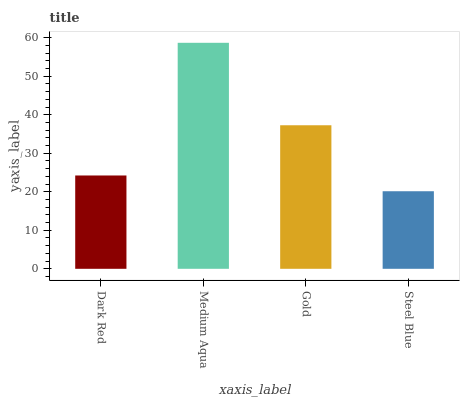Is Steel Blue the minimum?
Answer yes or no. Yes. Is Medium Aqua the maximum?
Answer yes or no. Yes. Is Gold the minimum?
Answer yes or no. No. Is Gold the maximum?
Answer yes or no. No. Is Medium Aqua greater than Gold?
Answer yes or no. Yes. Is Gold less than Medium Aqua?
Answer yes or no. Yes. Is Gold greater than Medium Aqua?
Answer yes or no. No. Is Medium Aqua less than Gold?
Answer yes or no. No. Is Gold the high median?
Answer yes or no. Yes. Is Dark Red the low median?
Answer yes or no. Yes. Is Dark Red the high median?
Answer yes or no. No. Is Gold the low median?
Answer yes or no. No. 